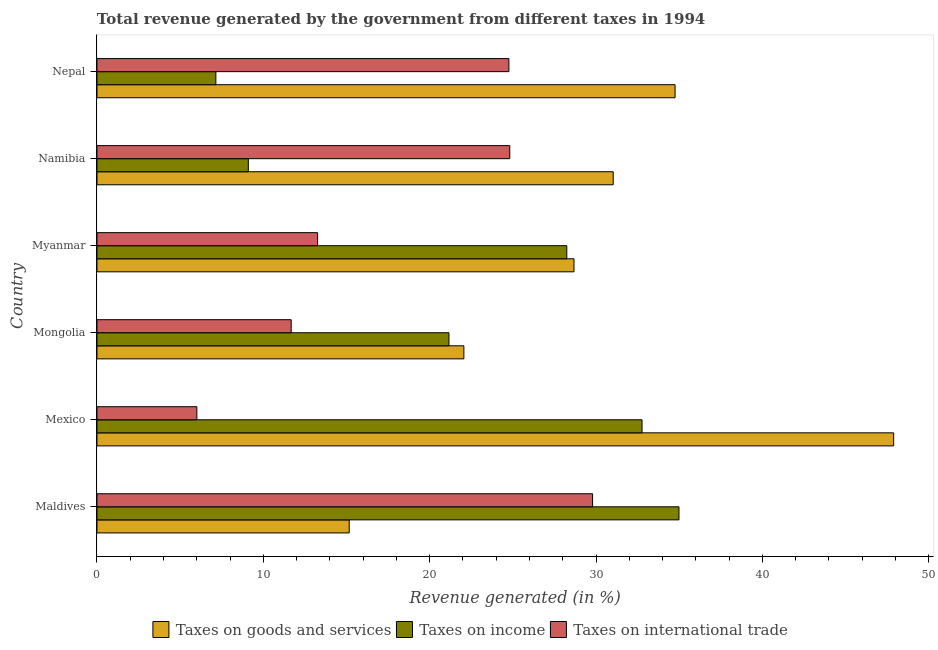How many different coloured bars are there?
Provide a succinct answer. 3. How many groups of bars are there?
Give a very brief answer. 6. Are the number of bars per tick equal to the number of legend labels?
Provide a short and direct response. Yes. Are the number of bars on each tick of the Y-axis equal?
Your response must be concise. Yes. How many bars are there on the 4th tick from the bottom?
Offer a terse response. 3. What is the label of the 3rd group of bars from the top?
Give a very brief answer. Myanmar. What is the percentage of revenue generated by tax on international trade in Maldives?
Provide a succinct answer. 29.79. Across all countries, what is the maximum percentage of revenue generated by tax on international trade?
Provide a succinct answer. 29.79. Across all countries, what is the minimum percentage of revenue generated by tax on international trade?
Provide a succinct answer. 6. In which country was the percentage of revenue generated by tax on international trade maximum?
Make the answer very short. Maldives. In which country was the percentage of revenue generated by taxes on goods and services minimum?
Your answer should be very brief. Maldives. What is the total percentage of revenue generated by taxes on income in the graph?
Offer a terse response. 133.4. What is the difference between the percentage of revenue generated by taxes on income in Mexico and that in Namibia?
Your answer should be compact. 23.67. What is the difference between the percentage of revenue generated by taxes on income in Mongolia and the percentage of revenue generated by tax on international trade in Myanmar?
Your response must be concise. 7.9. What is the average percentage of revenue generated by taxes on income per country?
Your response must be concise. 22.23. What is the difference between the percentage of revenue generated by taxes on income and percentage of revenue generated by taxes on goods and services in Mongolia?
Ensure brevity in your answer.  -0.9. In how many countries, is the percentage of revenue generated by taxes on income greater than 36 %?
Make the answer very short. 0. What is the ratio of the percentage of revenue generated by taxes on goods and services in Myanmar to that in Namibia?
Your answer should be very brief. 0.92. What is the difference between the highest and the second highest percentage of revenue generated by taxes on goods and services?
Provide a short and direct response. 13.14. What is the difference between the highest and the lowest percentage of revenue generated by taxes on income?
Give a very brief answer. 27.84. Is the sum of the percentage of revenue generated by tax on international trade in Mexico and Namibia greater than the maximum percentage of revenue generated by taxes on goods and services across all countries?
Make the answer very short. No. What does the 2nd bar from the top in Namibia represents?
Keep it short and to the point. Taxes on income. What does the 2nd bar from the bottom in Mongolia represents?
Your answer should be very brief. Taxes on income. Are all the bars in the graph horizontal?
Offer a terse response. Yes. How many countries are there in the graph?
Your answer should be very brief. 6. What is the difference between two consecutive major ticks on the X-axis?
Your answer should be very brief. 10. Does the graph contain any zero values?
Your answer should be very brief. No. What is the title of the graph?
Keep it short and to the point. Total revenue generated by the government from different taxes in 1994. What is the label or title of the X-axis?
Keep it short and to the point. Revenue generated (in %). What is the Revenue generated (in %) of Taxes on goods and services in Maldives?
Your answer should be compact. 15.16. What is the Revenue generated (in %) in Taxes on income in Maldives?
Your answer should be compact. 34.98. What is the Revenue generated (in %) in Taxes on international trade in Maldives?
Give a very brief answer. 29.79. What is the Revenue generated (in %) in Taxes on goods and services in Mexico?
Offer a terse response. 47.89. What is the Revenue generated (in %) of Taxes on income in Mexico?
Your answer should be very brief. 32.76. What is the Revenue generated (in %) in Taxes on international trade in Mexico?
Ensure brevity in your answer.  6. What is the Revenue generated (in %) of Taxes on goods and services in Mongolia?
Give a very brief answer. 22.05. What is the Revenue generated (in %) of Taxes on income in Mongolia?
Your answer should be very brief. 21.16. What is the Revenue generated (in %) in Taxes on international trade in Mongolia?
Make the answer very short. 11.67. What is the Revenue generated (in %) in Taxes on goods and services in Myanmar?
Provide a succinct answer. 28.67. What is the Revenue generated (in %) in Taxes on income in Myanmar?
Make the answer very short. 28.24. What is the Revenue generated (in %) in Taxes on international trade in Myanmar?
Make the answer very short. 13.26. What is the Revenue generated (in %) in Taxes on goods and services in Namibia?
Keep it short and to the point. 31.03. What is the Revenue generated (in %) in Taxes on income in Namibia?
Provide a succinct answer. 9.1. What is the Revenue generated (in %) of Taxes on international trade in Namibia?
Ensure brevity in your answer.  24.81. What is the Revenue generated (in %) of Taxes on goods and services in Nepal?
Make the answer very short. 34.75. What is the Revenue generated (in %) of Taxes on income in Nepal?
Offer a very short reply. 7.15. What is the Revenue generated (in %) of Taxes on international trade in Nepal?
Ensure brevity in your answer.  24.76. Across all countries, what is the maximum Revenue generated (in %) in Taxes on goods and services?
Give a very brief answer. 47.89. Across all countries, what is the maximum Revenue generated (in %) of Taxes on income?
Provide a short and direct response. 34.98. Across all countries, what is the maximum Revenue generated (in %) in Taxes on international trade?
Your answer should be compact. 29.79. Across all countries, what is the minimum Revenue generated (in %) of Taxes on goods and services?
Provide a short and direct response. 15.16. Across all countries, what is the minimum Revenue generated (in %) in Taxes on income?
Provide a short and direct response. 7.15. Across all countries, what is the minimum Revenue generated (in %) of Taxes on international trade?
Your answer should be compact. 6. What is the total Revenue generated (in %) in Taxes on goods and services in the graph?
Offer a terse response. 179.56. What is the total Revenue generated (in %) of Taxes on income in the graph?
Provide a succinct answer. 133.4. What is the total Revenue generated (in %) in Taxes on international trade in the graph?
Keep it short and to the point. 110.31. What is the difference between the Revenue generated (in %) in Taxes on goods and services in Maldives and that in Mexico?
Make the answer very short. -32.73. What is the difference between the Revenue generated (in %) in Taxes on income in Maldives and that in Mexico?
Offer a terse response. 2.22. What is the difference between the Revenue generated (in %) of Taxes on international trade in Maldives and that in Mexico?
Your answer should be very brief. 23.79. What is the difference between the Revenue generated (in %) of Taxes on goods and services in Maldives and that in Mongolia?
Your answer should be very brief. -6.89. What is the difference between the Revenue generated (in %) in Taxes on income in Maldives and that in Mongolia?
Ensure brevity in your answer.  13.83. What is the difference between the Revenue generated (in %) of Taxes on international trade in Maldives and that in Mongolia?
Provide a short and direct response. 18.12. What is the difference between the Revenue generated (in %) in Taxes on goods and services in Maldives and that in Myanmar?
Provide a succinct answer. -13.51. What is the difference between the Revenue generated (in %) in Taxes on income in Maldives and that in Myanmar?
Your response must be concise. 6.74. What is the difference between the Revenue generated (in %) of Taxes on international trade in Maldives and that in Myanmar?
Provide a short and direct response. 16.53. What is the difference between the Revenue generated (in %) of Taxes on goods and services in Maldives and that in Namibia?
Ensure brevity in your answer.  -15.87. What is the difference between the Revenue generated (in %) of Taxes on income in Maldives and that in Namibia?
Your response must be concise. 25.89. What is the difference between the Revenue generated (in %) in Taxes on international trade in Maldives and that in Namibia?
Offer a terse response. 4.98. What is the difference between the Revenue generated (in %) in Taxes on goods and services in Maldives and that in Nepal?
Ensure brevity in your answer.  -19.59. What is the difference between the Revenue generated (in %) in Taxes on income in Maldives and that in Nepal?
Your answer should be compact. 27.84. What is the difference between the Revenue generated (in %) of Taxes on international trade in Maldives and that in Nepal?
Your response must be concise. 5.03. What is the difference between the Revenue generated (in %) in Taxes on goods and services in Mexico and that in Mongolia?
Keep it short and to the point. 25.83. What is the difference between the Revenue generated (in %) in Taxes on income in Mexico and that in Mongolia?
Keep it short and to the point. 11.61. What is the difference between the Revenue generated (in %) in Taxes on international trade in Mexico and that in Mongolia?
Provide a short and direct response. -5.67. What is the difference between the Revenue generated (in %) of Taxes on goods and services in Mexico and that in Myanmar?
Keep it short and to the point. 19.22. What is the difference between the Revenue generated (in %) in Taxes on income in Mexico and that in Myanmar?
Offer a terse response. 4.52. What is the difference between the Revenue generated (in %) in Taxes on international trade in Mexico and that in Myanmar?
Offer a very short reply. -7.26. What is the difference between the Revenue generated (in %) in Taxes on goods and services in Mexico and that in Namibia?
Offer a very short reply. 16.86. What is the difference between the Revenue generated (in %) of Taxes on income in Mexico and that in Namibia?
Provide a short and direct response. 23.67. What is the difference between the Revenue generated (in %) in Taxes on international trade in Mexico and that in Namibia?
Make the answer very short. -18.81. What is the difference between the Revenue generated (in %) in Taxes on goods and services in Mexico and that in Nepal?
Your response must be concise. 13.14. What is the difference between the Revenue generated (in %) in Taxes on income in Mexico and that in Nepal?
Provide a short and direct response. 25.62. What is the difference between the Revenue generated (in %) in Taxes on international trade in Mexico and that in Nepal?
Provide a short and direct response. -18.76. What is the difference between the Revenue generated (in %) of Taxes on goods and services in Mongolia and that in Myanmar?
Keep it short and to the point. -6.62. What is the difference between the Revenue generated (in %) in Taxes on income in Mongolia and that in Myanmar?
Provide a succinct answer. -7.08. What is the difference between the Revenue generated (in %) in Taxes on international trade in Mongolia and that in Myanmar?
Provide a succinct answer. -1.59. What is the difference between the Revenue generated (in %) of Taxes on goods and services in Mongolia and that in Namibia?
Provide a short and direct response. -8.98. What is the difference between the Revenue generated (in %) of Taxes on income in Mongolia and that in Namibia?
Give a very brief answer. 12.06. What is the difference between the Revenue generated (in %) in Taxes on international trade in Mongolia and that in Namibia?
Give a very brief answer. -13.14. What is the difference between the Revenue generated (in %) of Taxes on goods and services in Mongolia and that in Nepal?
Offer a very short reply. -12.7. What is the difference between the Revenue generated (in %) in Taxes on income in Mongolia and that in Nepal?
Offer a terse response. 14.01. What is the difference between the Revenue generated (in %) in Taxes on international trade in Mongolia and that in Nepal?
Your response must be concise. -13.09. What is the difference between the Revenue generated (in %) in Taxes on goods and services in Myanmar and that in Namibia?
Offer a terse response. -2.36. What is the difference between the Revenue generated (in %) of Taxes on income in Myanmar and that in Namibia?
Give a very brief answer. 19.14. What is the difference between the Revenue generated (in %) of Taxes on international trade in Myanmar and that in Namibia?
Offer a very short reply. -11.55. What is the difference between the Revenue generated (in %) in Taxes on goods and services in Myanmar and that in Nepal?
Your answer should be compact. -6.08. What is the difference between the Revenue generated (in %) of Taxes on income in Myanmar and that in Nepal?
Your answer should be very brief. 21.09. What is the difference between the Revenue generated (in %) of Taxes on international trade in Myanmar and that in Nepal?
Offer a very short reply. -11.5. What is the difference between the Revenue generated (in %) in Taxes on goods and services in Namibia and that in Nepal?
Provide a succinct answer. -3.72. What is the difference between the Revenue generated (in %) in Taxes on income in Namibia and that in Nepal?
Your response must be concise. 1.95. What is the difference between the Revenue generated (in %) in Taxes on international trade in Namibia and that in Nepal?
Your response must be concise. 0.05. What is the difference between the Revenue generated (in %) in Taxes on goods and services in Maldives and the Revenue generated (in %) in Taxes on income in Mexico?
Your response must be concise. -17.6. What is the difference between the Revenue generated (in %) in Taxes on goods and services in Maldives and the Revenue generated (in %) in Taxes on international trade in Mexico?
Keep it short and to the point. 9.16. What is the difference between the Revenue generated (in %) of Taxes on income in Maldives and the Revenue generated (in %) of Taxes on international trade in Mexico?
Offer a terse response. 28.98. What is the difference between the Revenue generated (in %) in Taxes on goods and services in Maldives and the Revenue generated (in %) in Taxes on income in Mongolia?
Ensure brevity in your answer.  -6. What is the difference between the Revenue generated (in %) in Taxes on goods and services in Maldives and the Revenue generated (in %) in Taxes on international trade in Mongolia?
Provide a short and direct response. 3.49. What is the difference between the Revenue generated (in %) of Taxes on income in Maldives and the Revenue generated (in %) of Taxes on international trade in Mongolia?
Keep it short and to the point. 23.31. What is the difference between the Revenue generated (in %) of Taxes on goods and services in Maldives and the Revenue generated (in %) of Taxes on income in Myanmar?
Your response must be concise. -13.08. What is the difference between the Revenue generated (in %) of Taxes on goods and services in Maldives and the Revenue generated (in %) of Taxes on international trade in Myanmar?
Offer a very short reply. 1.9. What is the difference between the Revenue generated (in %) of Taxes on income in Maldives and the Revenue generated (in %) of Taxes on international trade in Myanmar?
Your answer should be very brief. 21.72. What is the difference between the Revenue generated (in %) in Taxes on goods and services in Maldives and the Revenue generated (in %) in Taxes on income in Namibia?
Provide a short and direct response. 6.06. What is the difference between the Revenue generated (in %) of Taxes on goods and services in Maldives and the Revenue generated (in %) of Taxes on international trade in Namibia?
Your answer should be compact. -9.65. What is the difference between the Revenue generated (in %) of Taxes on income in Maldives and the Revenue generated (in %) of Taxes on international trade in Namibia?
Keep it short and to the point. 10.17. What is the difference between the Revenue generated (in %) of Taxes on goods and services in Maldives and the Revenue generated (in %) of Taxes on income in Nepal?
Offer a very short reply. 8.02. What is the difference between the Revenue generated (in %) in Taxes on goods and services in Maldives and the Revenue generated (in %) in Taxes on international trade in Nepal?
Provide a succinct answer. -9.6. What is the difference between the Revenue generated (in %) of Taxes on income in Maldives and the Revenue generated (in %) of Taxes on international trade in Nepal?
Your answer should be very brief. 10.22. What is the difference between the Revenue generated (in %) of Taxes on goods and services in Mexico and the Revenue generated (in %) of Taxes on income in Mongolia?
Your answer should be compact. 26.73. What is the difference between the Revenue generated (in %) of Taxes on goods and services in Mexico and the Revenue generated (in %) of Taxes on international trade in Mongolia?
Your response must be concise. 36.21. What is the difference between the Revenue generated (in %) in Taxes on income in Mexico and the Revenue generated (in %) in Taxes on international trade in Mongolia?
Offer a terse response. 21.09. What is the difference between the Revenue generated (in %) in Taxes on goods and services in Mexico and the Revenue generated (in %) in Taxes on income in Myanmar?
Make the answer very short. 19.65. What is the difference between the Revenue generated (in %) of Taxes on goods and services in Mexico and the Revenue generated (in %) of Taxes on international trade in Myanmar?
Your answer should be very brief. 34.63. What is the difference between the Revenue generated (in %) in Taxes on income in Mexico and the Revenue generated (in %) in Taxes on international trade in Myanmar?
Make the answer very short. 19.5. What is the difference between the Revenue generated (in %) of Taxes on goods and services in Mexico and the Revenue generated (in %) of Taxes on income in Namibia?
Provide a short and direct response. 38.79. What is the difference between the Revenue generated (in %) in Taxes on goods and services in Mexico and the Revenue generated (in %) in Taxes on international trade in Namibia?
Your answer should be compact. 23.08. What is the difference between the Revenue generated (in %) of Taxes on income in Mexico and the Revenue generated (in %) of Taxes on international trade in Namibia?
Keep it short and to the point. 7.95. What is the difference between the Revenue generated (in %) in Taxes on goods and services in Mexico and the Revenue generated (in %) in Taxes on income in Nepal?
Ensure brevity in your answer.  40.74. What is the difference between the Revenue generated (in %) of Taxes on goods and services in Mexico and the Revenue generated (in %) of Taxes on international trade in Nepal?
Your answer should be very brief. 23.13. What is the difference between the Revenue generated (in %) in Taxes on income in Mexico and the Revenue generated (in %) in Taxes on international trade in Nepal?
Ensure brevity in your answer.  8. What is the difference between the Revenue generated (in %) in Taxes on goods and services in Mongolia and the Revenue generated (in %) in Taxes on income in Myanmar?
Offer a very short reply. -6.19. What is the difference between the Revenue generated (in %) of Taxes on goods and services in Mongolia and the Revenue generated (in %) of Taxes on international trade in Myanmar?
Offer a terse response. 8.79. What is the difference between the Revenue generated (in %) of Taxes on income in Mongolia and the Revenue generated (in %) of Taxes on international trade in Myanmar?
Provide a succinct answer. 7.9. What is the difference between the Revenue generated (in %) in Taxes on goods and services in Mongolia and the Revenue generated (in %) in Taxes on income in Namibia?
Keep it short and to the point. 12.96. What is the difference between the Revenue generated (in %) of Taxes on goods and services in Mongolia and the Revenue generated (in %) of Taxes on international trade in Namibia?
Provide a short and direct response. -2.76. What is the difference between the Revenue generated (in %) in Taxes on income in Mongolia and the Revenue generated (in %) in Taxes on international trade in Namibia?
Give a very brief answer. -3.65. What is the difference between the Revenue generated (in %) of Taxes on goods and services in Mongolia and the Revenue generated (in %) of Taxes on income in Nepal?
Keep it short and to the point. 14.91. What is the difference between the Revenue generated (in %) of Taxes on goods and services in Mongolia and the Revenue generated (in %) of Taxes on international trade in Nepal?
Give a very brief answer. -2.71. What is the difference between the Revenue generated (in %) in Taxes on income in Mongolia and the Revenue generated (in %) in Taxes on international trade in Nepal?
Your answer should be very brief. -3.6. What is the difference between the Revenue generated (in %) in Taxes on goods and services in Myanmar and the Revenue generated (in %) in Taxes on income in Namibia?
Make the answer very short. 19.57. What is the difference between the Revenue generated (in %) of Taxes on goods and services in Myanmar and the Revenue generated (in %) of Taxes on international trade in Namibia?
Provide a short and direct response. 3.86. What is the difference between the Revenue generated (in %) in Taxes on income in Myanmar and the Revenue generated (in %) in Taxes on international trade in Namibia?
Provide a short and direct response. 3.43. What is the difference between the Revenue generated (in %) in Taxes on goods and services in Myanmar and the Revenue generated (in %) in Taxes on income in Nepal?
Offer a very short reply. 21.53. What is the difference between the Revenue generated (in %) in Taxes on goods and services in Myanmar and the Revenue generated (in %) in Taxes on international trade in Nepal?
Offer a very short reply. 3.91. What is the difference between the Revenue generated (in %) in Taxes on income in Myanmar and the Revenue generated (in %) in Taxes on international trade in Nepal?
Provide a succinct answer. 3.48. What is the difference between the Revenue generated (in %) in Taxes on goods and services in Namibia and the Revenue generated (in %) in Taxes on income in Nepal?
Offer a very short reply. 23.88. What is the difference between the Revenue generated (in %) of Taxes on goods and services in Namibia and the Revenue generated (in %) of Taxes on international trade in Nepal?
Offer a terse response. 6.27. What is the difference between the Revenue generated (in %) of Taxes on income in Namibia and the Revenue generated (in %) of Taxes on international trade in Nepal?
Provide a short and direct response. -15.66. What is the average Revenue generated (in %) of Taxes on goods and services per country?
Keep it short and to the point. 29.93. What is the average Revenue generated (in %) of Taxes on income per country?
Ensure brevity in your answer.  22.23. What is the average Revenue generated (in %) in Taxes on international trade per country?
Keep it short and to the point. 18.38. What is the difference between the Revenue generated (in %) of Taxes on goods and services and Revenue generated (in %) of Taxes on income in Maldives?
Your answer should be compact. -19.82. What is the difference between the Revenue generated (in %) in Taxes on goods and services and Revenue generated (in %) in Taxes on international trade in Maldives?
Provide a short and direct response. -14.63. What is the difference between the Revenue generated (in %) in Taxes on income and Revenue generated (in %) in Taxes on international trade in Maldives?
Your answer should be compact. 5.19. What is the difference between the Revenue generated (in %) of Taxes on goods and services and Revenue generated (in %) of Taxes on income in Mexico?
Keep it short and to the point. 15.12. What is the difference between the Revenue generated (in %) of Taxes on goods and services and Revenue generated (in %) of Taxes on international trade in Mexico?
Give a very brief answer. 41.88. What is the difference between the Revenue generated (in %) in Taxes on income and Revenue generated (in %) in Taxes on international trade in Mexico?
Your response must be concise. 26.76. What is the difference between the Revenue generated (in %) of Taxes on goods and services and Revenue generated (in %) of Taxes on income in Mongolia?
Provide a succinct answer. 0.9. What is the difference between the Revenue generated (in %) in Taxes on goods and services and Revenue generated (in %) in Taxes on international trade in Mongolia?
Your response must be concise. 10.38. What is the difference between the Revenue generated (in %) in Taxes on income and Revenue generated (in %) in Taxes on international trade in Mongolia?
Your answer should be compact. 9.48. What is the difference between the Revenue generated (in %) in Taxes on goods and services and Revenue generated (in %) in Taxes on income in Myanmar?
Offer a terse response. 0.43. What is the difference between the Revenue generated (in %) in Taxes on goods and services and Revenue generated (in %) in Taxes on international trade in Myanmar?
Keep it short and to the point. 15.41. What is the difference between the Revenue generated (in %) in Taxes on income and Revenue generated (in %) in Taxes on international trade in Myanmar?
Your answer should be very brief. 14.98. What is the difference between the Revenue generated (in %) of Taxes on goods and services and Revenue generated (in %) of Taxes on income in Namibia?
Your answer should be compact. 21.93. What is the difference between the Revenue generated (in %) of Taxes on goods and services and Revenue generated (in %) of Taxes on international trade in Namibia?
Provide a short and direct response. 6.22. What is the difference between the Revenue generated (in %) of Taxes on income and Revenue generated (in %) of Taxes on international trade in Namibia?
Offer a terse response. -15.71. What is the difference between the Revenue generated (in %) of Taxes on goods and services and Revenue generated (in %) of Taxes on income in Nepal?
Your answer should be compact. 27.6. What is the difference between the Revenue generated (in %) of Taxes on goods and services and Revenue generated (in %) of Taxes on international trade in Nepal?
Your answer should be compact. 9.99. What is the difference between the Revenue generated (in %) in Taxes on income and Revenue generated (in %) in Taxes on international trade in Nepal?
Offer a terse response. -17.61. What is the ratio of the Revenue generated (in %) of Taxes on goods and services in Maldives to that in Mexico?
Keep it short and to the point. 0.32. What is the ratio of the Revenue generated (in %) in Taxes on income in Maldives to that in Mexico?
Give a very brief answer. 1.07. What is the ratio of the Revenue generated (in %) in Taxes on international trade in Maldives to that in Mexico?
Your response must be concise. 4.96. What is the ratio of the Revenue generated (in %) in Taxes on goods and services in Maldives to that in Mongolia?
Keep it short and to the point. 0.69. What is the ratio of the Revenue generated (in %) of Taxes on income in Maldives to that in Mongolia?
Your response must be concise. 1.65. What is the ratio of the Revenue generated (in %) in Taxes on international trade in Maldives to that in Mongolia?
Your answer should be very brief. 2.55. What is the ratio of the Revenue generated (in %) in Taxes on goods and services in Maldives to that in Myanmar?
Provide a short and direct response. 0.53. What is the ratio of the Revenue generated (in %) of Taxes on income in Maldives to that in Myanmar?
Provide a short and direct response. 1.24. What is the ratio of the Revenue generated (in %) of Taxes on international trade in Maldives to that in Myanmar?
Your response must be concise. 2.25. What is the ratio of the Revenue generated (in %) of Taxes on goods and services in Maldives to that in Namibia?
Offer a very short reply. 0.49. What is the ratio of the Revenue generated (in %) in Taxes on income in Maldives to that in Namibia?
Provide a short and direct response. 3.85. What is the ratio of the Revenue generated (in %) in Taxes on international trade in Maldives to that in Namibia?
Provide a short and direct response. 1.2. What is the ratio of the Revenue generated (in %) of Taxes on goods and services in Maldives to that in Nepal?
Ensure brevity in your answer.  0.44. What is the ratio of the Revenue generated (in %) in Taxes on income in Maldives to that in Nepal?
Your answer should be compact. 4.9. What is the ratio of the Revenue generated (in %) of Taxes on international trade in Maldives to that in Nepal?
Your response must be concise. 1.2. What is the ratio of the Revenue generated (in %) in Taxes on goods and services in Mexico to that in Mongolia?
Keep it short and to the point. 2.17. What is the ratio of the Revenue generated (in %) in Taxes on income in Mexico to that in Mongolia?
Offer a terse response. 1.55. What is the ratio of the Revenue generated (in %) of Taxes on international trade in Mexico to that in Mongolia?
Offer a very short reply. 0.51. What is the ratio of the Revenue generated (in %) in Taxes on goods and services in Mexico to that in Myanmar?
Offer a very short reply. 1.67. What is the ratio of the Revenue generated (in %) of Taxes on income in Mexico to that in Myanmar?
Give a very brief answer. 1.16. What is the ratio of the Revenue generated (in %) of Taxes on international trade in Mexico to that in Myanmar?
Your answer should be compact. 0.45. What is the ratio of the Revenue generated (in %) in Taxes on goods and services in Mexico to that in Namibia?
Make the answer very short. 1.54. What is the ratio of the Revenue generated (in %) of Taxes on income in Mexico to that in Namibia?
Make the answer very short. 3.6. What is the ratio of the Revenue generated (in %) in Taxes on international trade in Mexico to that in Namibia?
Your answer should be compact. 0.24. What is the ratio of the Revenue generated (in %) of Taxes on goods and services in Mexico to that in Nepal?
Keep it short and to the point. 1.38. What is the ratio of the Revenue generated (in %) of Taxes on income in Mexico to that in Nepal?
Offer a terse response. 4.58. What is the ratio of the Revenue generated (in %) of Taxes on international trade in Mexico to that in Nepal?
Your answer should be very brief. 0.24. What is the ratio of the Revenue generated (in %) of Taxes on goods and services in Mongolia to that in Myanmar?
Offer a terse response. 0.77. What is the ratio of the Revenue generated (in %) in Taxes on income in Mongolia to that in Myanmar?
Give a very brief answer. 0.75. What is the ratio of the Revenue generated (in %) in Taxes on international trade in Mongolia to that in Myanmar?
Give a very brief answer. 0.88. What is the ratio of the Revenue generated (in %) in Taxes on goods and services in Mongolia to that in Namibia?
Your answer should be compact. 0.71. What is the ratio of the Revenue generated (in %) in Taxes on income in Mongolia to that in Namibia?
Your response must be concise. 2.33. What is the ratio of the Revenue generated (in %) of Taxes on international trade in Mongolia to that in Namibia?
Provide a short and direct response. 0.47. What is the ratio of the Revenue generated (in %) of Taxes on goods and services in Mongolia to that in Nepal?
Your response must be concise. 0.63. What is the ratio of the Revenue generated (in %) of Taxes on income in Mongolia to that in Nepal?
Provide a succinct answer. 2.96. What is the ratio of the Revenue generated (in %) in Taxes on international trade in Mongolia to that in Nepal?
Offer a terse response. 0.47. What is the ratio of the Revenue generated (in %) of Taxes on goods and services in Myanmar to that in Namibia?
Keep it short and to the point. 0.92. What is the ratio of the Revenue generated (in %) of Taxes on income in Myanmar to that in Namibia?
Make the answer very short. 3.1. What is the ratio of the Revenue generated (in %) of Taxes on international trade in Myanmar to that in Namibia?
Keep it short and to the point. 0.53. What is the ratio of the Revenue generated (in %) of Taxes on goods and services in Myanmar to that in Nepal?
Keep it short and to the point. 0.83. What is the ratio of the Revenue generated (in %) of Taxes on income in Myanmar to that in Nepal?
Give a very brief answer. 3.95. What is the ratio of the Revenue generated (in %) of Taxes on international trade in Myanmar to that in Nepal?
Make the answer very short. 0.54. What is the ratio of the Revenue generated (in %) of Taxes on goods and services in Namibia to that in Nepal?
Offer a very short reply. 0.89. What is the ratio of the Revenue generated (in %) in Taxes on income in Namibia to that in Nepal?
Offer a very short reply. 1.27. What is the ratio of the Revenue generated (in %) in Taxes on international trade in Namibia to that in Nepal?
Keep it short and to the point. 1. What is the difference between the highest and the second highest Revenue generated (in %) in Taxes on goods and services?
Keep it short and to the point. 13.14. What is the difference between the highest and the second highest Revenue generated (in %) in Taxes on income?
Give a very brief answer. 2.22. What is the difference between the highest and the second highest Revenue generated (in %) of Taxes on international trade?
Offer a very short reply. 4.98. What is the difference between the highest and the lowest Revenue generated (in %) of Taxes on goods and services?
Offer a terse response. 32.73. What is the difference between the highest and the lowest Revenue generated (in %) of Taxes on income?
Your response must be concise. 27.84. What is the difference between the highest and the lowest Revenue generated (in %) in Taxes on international trade?
Offer a very short reply. 23.79. 